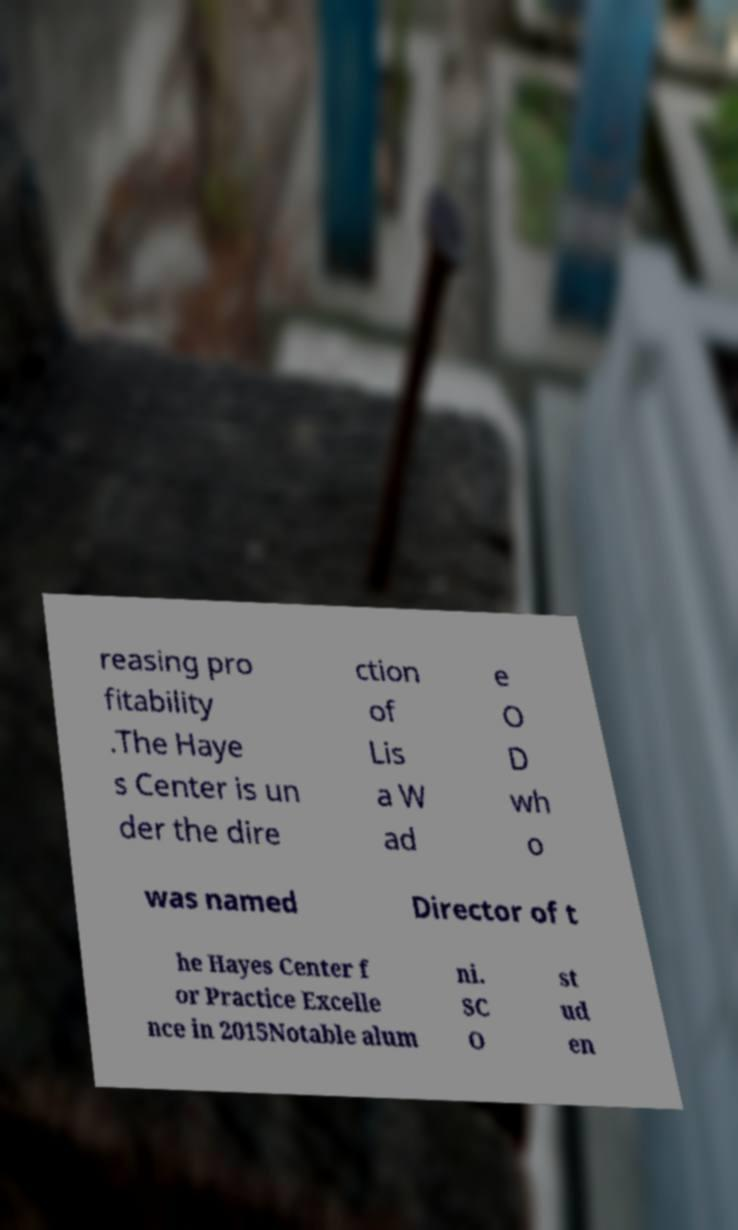Could you extract and type out the text from this image? reasing pro fitability .The Haye s Center is un der the dire ction of Lis a W ad e O D wh o was named Director of t he Hayes Center f or Practice Excelle nce in 2015Notable alum ni. SC O st ud en 